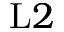Convert formula to latex. <formula><loc_0><loc_0><loc_500><loc_500>L 2</formula> 